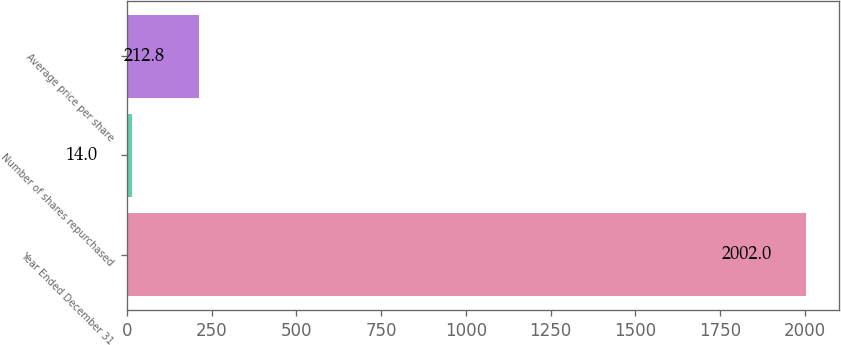Convert chart to OTSL. <chart><loc_0><loc_0><loc_500><loc_500><bar_chart><fcel>Year Ended December 31<fcel>Number of shares repurchased<fcel>Average price per share<nl><fcel>2002<fcel>14<fcel>212.8<nl></chart> 